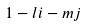<formula> <loc_0><loc_0><loc_500><loc_500>1 - l i - m j</formula> 